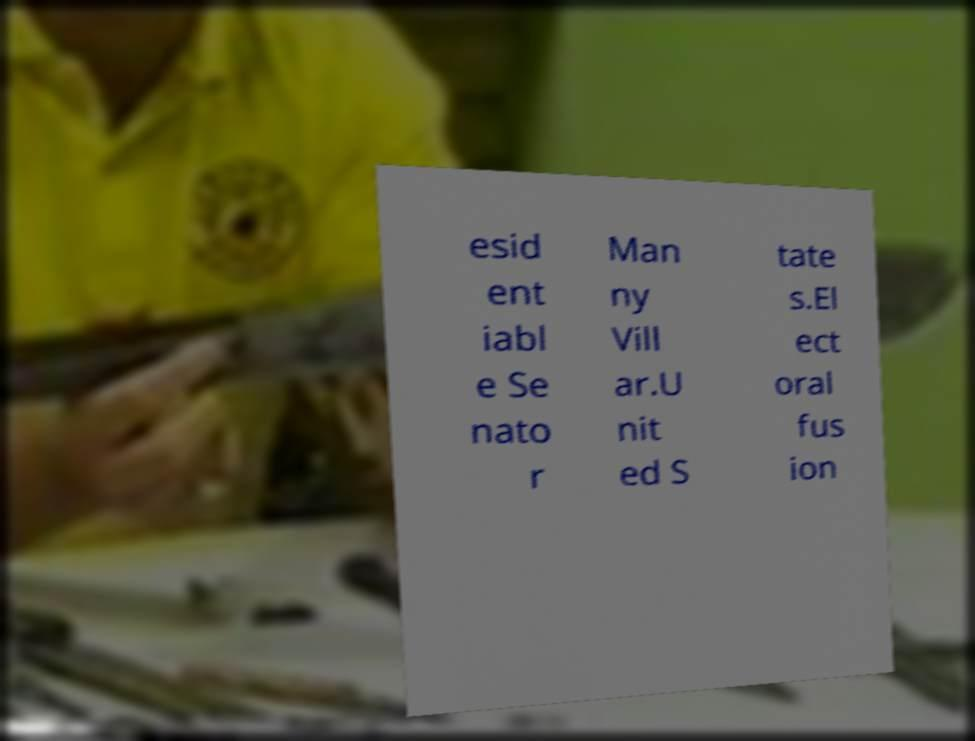There's text embedded in this image that I need extracted. Can you transcribe it verbatim? esid ent iabl e Se nato r Man ny Vill ar.U nit ed S tate s.El ect oral fus ion 